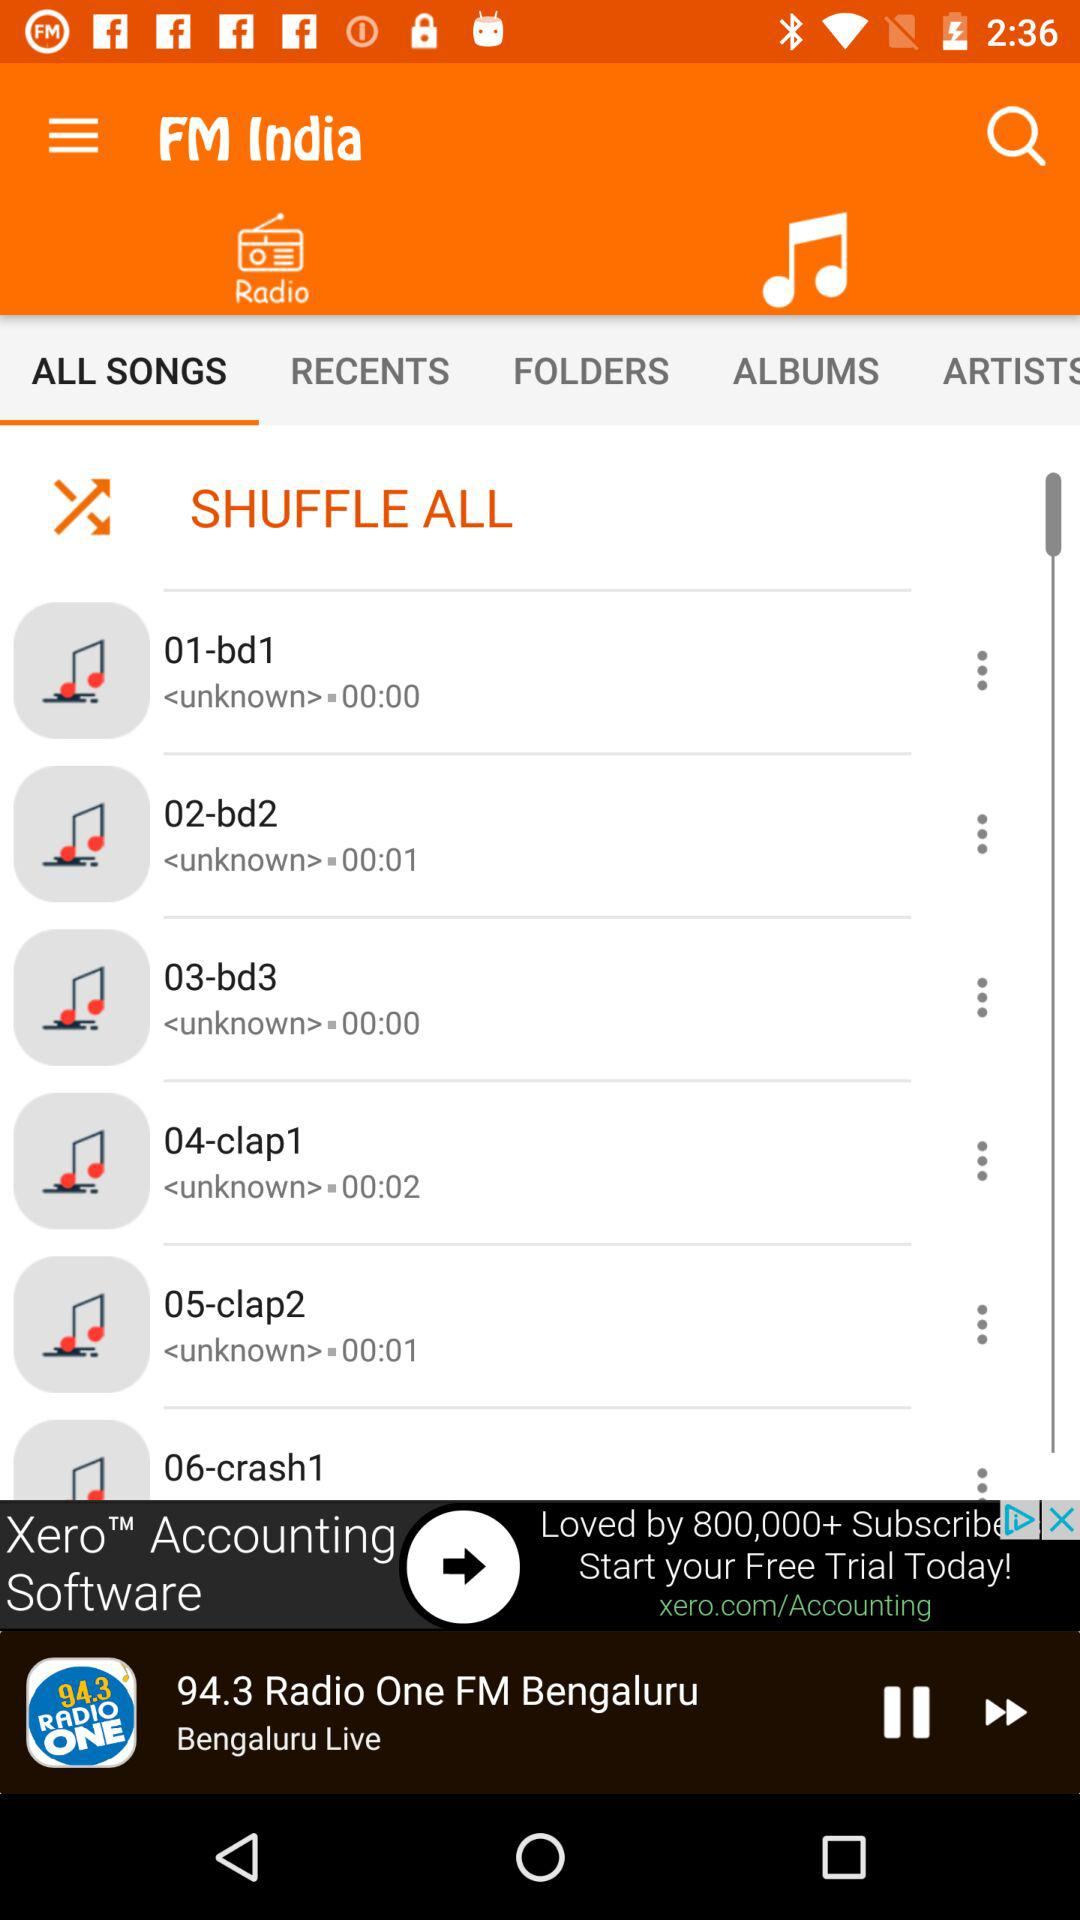What is the time duration of "04-clap1"? The time duration of "04-clap1" is 2 seconds. 